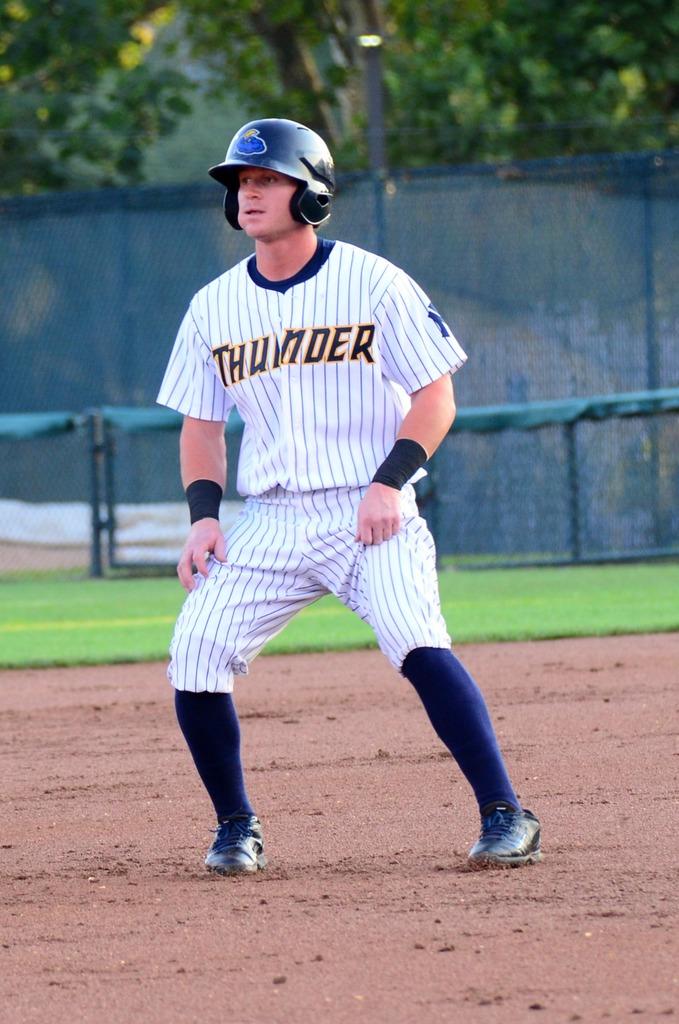What is the teams nickname?
Provide a succinct answer. Thunder. 